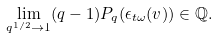Convert formula to latex. <formula><loc_0><loc_0><loc_500><loc_500>\lim _ { q ^ { 1 / 2 } \to 1 } ( q - 1 ) P _ { q } ( \epsilon _ { t \omega } ( v ) ) \in \mathbb { Q } .</formula> 